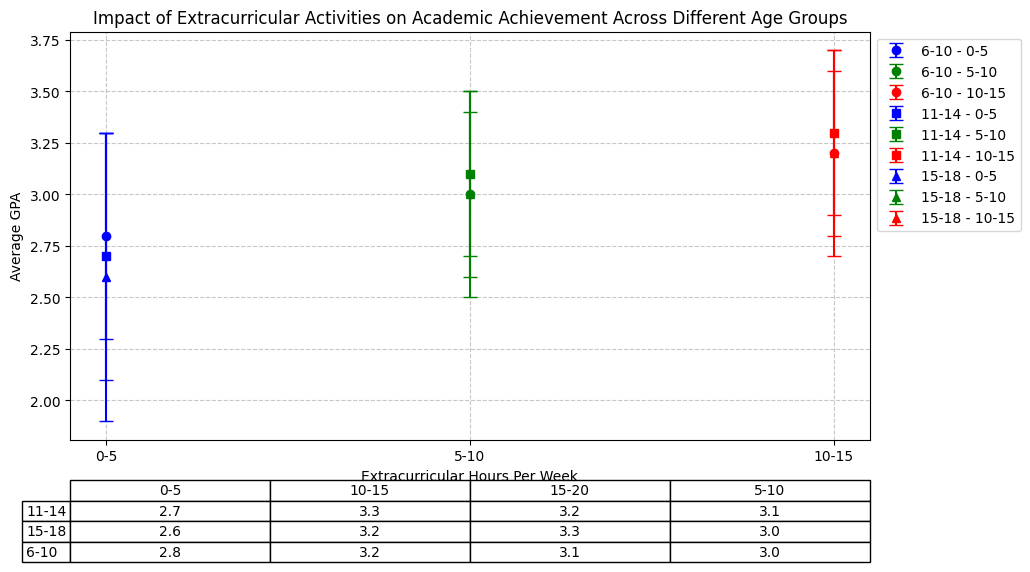Which age group and extracurricular hours combination has the highest average GPA? To identify the combination with the highest average GPA, we need to compare the average GPA for all age groups and extracurricular hours. The highest value visible in the table and the plot is 3.3. Both the "11-14, 10-15 hours" and "15-18, 15-20 hours" groups reach this GPA.
Answer: 11-14, 10-15 hours and 15-18, 15-20 hours How does the average GPA for the 6-10 age group change as extracurricular hours increase from 0-5 to 10-15 hours per week? For the 6-10 age group, the average GPA starts at 2.8 with 0-5 hours, then increases to 3.0 with 5-10 hours, and further increases to 3.2 with 10-15 hours of extracurricular activities per week.
Answer: Increases from 2.8 to 3.2 Which extracurricular hours per week category shows the least variation in GPA for the 11-14 age group? To determine the least variation, we look for the smallest standard deviation. For the 11-14 group, 0-5 hours has a standard deviation of 0.6, 5-10 has 0.4, 10-15 has 0.4, and 15-20 has 0.5. The smallest standard deviation is in the 5-10 and 10-15 hours per week categories.
Answer: 5-10 and 10-15 hours per week What trend is observed in the 15-18 age group when considering the average GPA as extracurricular hours per week increase from 0-5 to 15-20? The trend in the 15-18 age group shows that the average GPA increases with more extracurricular hours. It starts at 2.6 for 0-5 hours, increases to 3.0 for 5-10 hours, further increases to 3.2 for 10-15 hours, and finally reaches 3.3 for 15-20 hours per week.
Answer: Increasing GPA trend Which age group shows the most improvement in GPA from 0-5 to 10-15 extracurricular hours per week? To measure improvement, we need to calculate the difference in GPA from 0-5 to 10-15 hours for each age group. For the 6-10 group, it's 3.2 - 2.8 = 0.4; for the 11-14 group, it's 3.3 - 2.7 = 0.6; and for the 15-18 group, it's 3.2 - 2.6 = 0.6. Both the 11-14 and 15-18 groups show an improvement of 0.6.
Answer: 11-14 and 15-18 age groups Is there any age group where the average GPA decreases when extracurricular hours increase from 10-15 to 15-20? For the 6-10 age group, the average GPA decreases from 3.2 (10-15 hours) to 3.1 (15-20 hours). This trend can be confirmed by comparing the average GPA values for each age group and hour range.
Answer: 6-10 age group Which category shows the largest standard deviation in GPA within the 15-18 age group? The standard deviations for the 15-18 age group are 0.7 (0-5 hours), 0.5 (5-10 hours), 0.5 (10-15 hours), and 0.4 (15-20 hours). The largest standard deviation is 0.7 for the 0-5 hours per week category.
Answer: 0-5 hours What is the difference in the average GPA between the 6-10 age group with 0-5 hours and the 11-14 age group with 0-5 hours of extracurricular activities? The average GPA for the 6-10 age group with 0-5 hours is 2.8, and for the 11-14 age group with 0-5 hours, it is 2.7. The difference is 2.8 - 2.7 = 0.1.
Answer: 0.1 